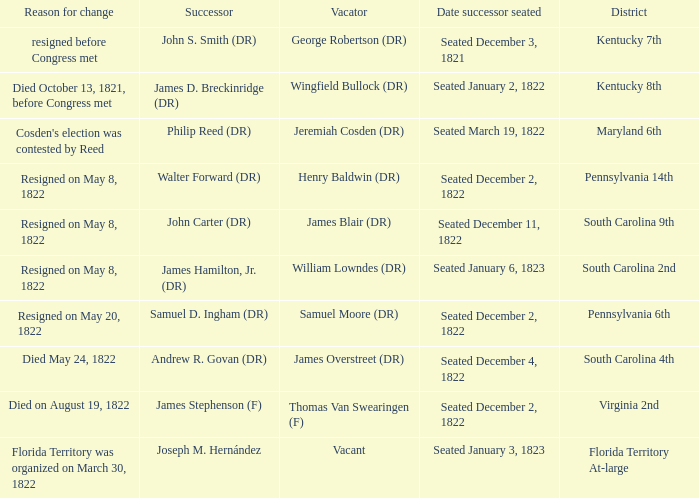Who is the successor when florida territory at-large is the district? Joseph M. Hernández. 